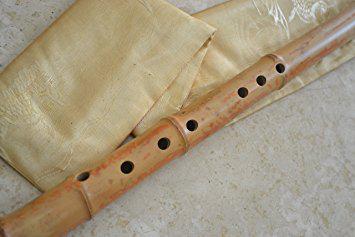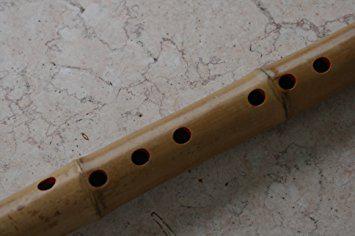The first image is the image on the left, the second image is the image on the right. Analyze the images presented: Is the assertion "Each image contains exactly one bamboo flute, and the left image shows a flute displayed diagonally and overlapping a folded band of cloth." valid? Answer yes or no. Yes. The first image is the image on the left, the second image is the image on the right. Examine the images to the left and right. Is the description "The left and right image contains the same number of flutes." accurate? Answer yes or no. Yes. 